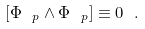Convert formula to latex. <formula><loc_0><loc_0><loc_500><loc_500>[ \Phi _ { \ p } \wedge \Phi _ { \ p } ] \equiv 0 \ .</formula> 